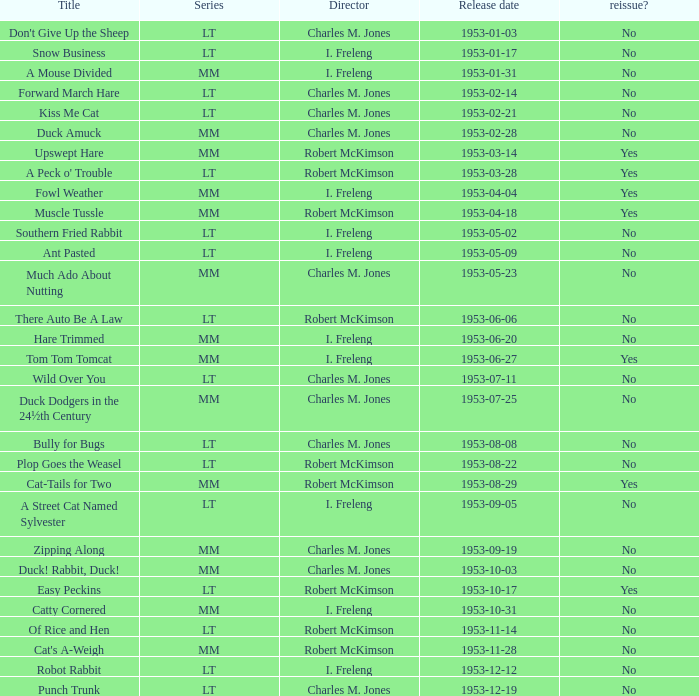What's the title for the release date of 1953-01-31 in the MM series, no reissue, and a director of I. Freleng? A Mouse Divided. 